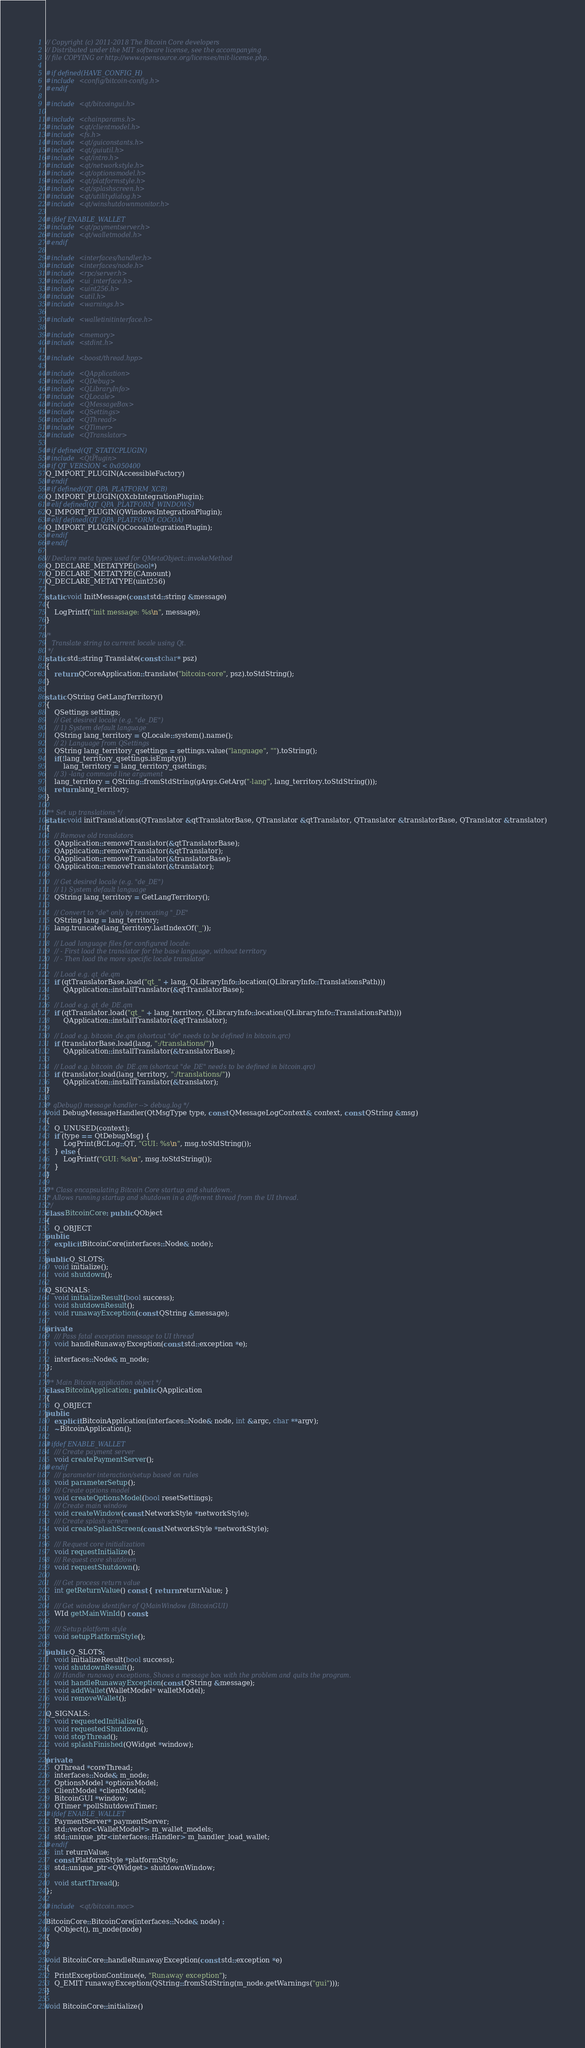Convert code to text. <code><loc_0><loc_0><loc_500><loc_500><_C++_>// Copyright (c) 2011-2018 The Bitcoin Core developers
// Distributed under the MIT software license, see the accompanying
// file COPYING or http://www.opensource.org/licenses/mit-license.php.

#if defined(HAVE_CONFIG_H)
#include <config/bitcoin-config.h>
#endif

#include <qt/bitcoingui.h>

#include <chainparams.h>
#include <qt/clientmodel.h>
#include <fs.h>
#include <qt/guiconstants.h>
#include <qt/guiutil.h>
#include <qt/intro.h>
#include <qt/networkstyle.h>
#include <qt/optionsmodel.h>
#include <qt/platformstyle.h>
#include <qt/splashscreen.h>
#include <qt/utilitydialog.h>
#include <qt/winshutdownmonitor.h>

#ifdef ENABLE_WALLET
#include <qt/paymentserver.h>
#include <qt/walletmodel.h>
#endif

#include <interfaces/handler.h>
#include <interfaces/node.h>
#include <rpc/server.h>
#include <ui_interface.h>
#include <uint256.h>
#include <util.h>
#include <warnings.h>

#include <walletinitinterface.h>

#include <memory>
#include <stdint.h>

#include <boost/thread.hpp>

#include <QApplication>
#include <QDebug>
#include <QLibraryInfo>
#include <QLocale>
#include <QMessageBox>
#include <QSettings>
#include <QThread>
#include <QTimer>
#include <QTranslator>

#if defined(QT_STATICPLUGIN)
#include <QtPlugin>
#if QT_VERSION < 0x050400
Q_IMPORT_PLUGIN(AccessibleFactory)
#endif
#if defined(QT_QPA_PLATFORM_XCB)
Q_IMPORT_PLUGIN(QXcbIntegrationPlugin);
#elif defined(QT_QPA_PLATFORM_WINDOWS)
Q_IMPORT_PLUGIN(QWindowsIntegrationPlugin);
#elif defined(QT_QPA_PLATFORM_COCOA)
Q_IMPORT_PLUGIN(QCocoaIntegrationPlugin);
#endif
#endif

// Declare meta types used for QMetaObject::invokeMethod
Q_DECLARE_METATYPE(bool*)
Q_DECLARE_METATYPE(CAmount)
Q_DECLARE_METATYPE(uint256)

static void InitMessage(const std::string &message)
{
    LogPrintf("init message: %s\n", message);
}

/*
   Translate string to current locale using Qt.
 */
static std::string Translate(const char* psz)
{
    return QCoreApplication::translate("bitcoin-core", psz).toStdString();
}

static QString GetLangTerritory()
{
    QSettings settings;
    // Get desired locale (e.g. "de_DE")
    // 1) System default language
    QString lang_territory = QLocale::system().name();
    // 2) Language from QSettings
    QString lang_territory_qsettings = settings.value("language", "").toString();
    if(!lang_territory_qsettings.isEmpty())
        lang_territory = lang_territory_qsettings;
    // 3) -lang command line argument
    lang_territory = QString::fromStdString(gArgs.GetArg("-lang", lang_territory.toStdString()));
    return lang_territory;
}

/** Set up translations */
static void initTranslations(QTranslator &qtTranslatorBase, QTranslator &qtTranslator, QTranslator &translatorBase, QTranslator &translator)
{
    // Remove old translators
    QApplication::removeTranslator(&qtTranslatorBase);
    QApplication::removeTranslator(&qtTranslator);
    QApplication::removeTranslator(&translatorBase);
    QApplication::removeTranslator(&translator);

    // Get desired locale (e.g. "de_DE")
    // 1) System default language
    QString lang_territory = GetLangTerritory();

    // Convert to "de" only by truncating "_DE"
    QString lang = lang_territory;
    lang.truncate(lang_territory.lastIndexOf('_'));

    // Load language files for configured locale:
    // - First load the translator for the base language, without territory
    // - Then load the more specific locale translator

    // Load e.g. qt_de.qm
    if (qtTranslatorBase.load("qt_" + lang, QLibraryInfo::location(QLibraryInfo::TranslationsPath)))
        QApplication::installTranslator(&qtTranslatorBase);

    // Load e.g. qt_de_DE.qm
    if (qtTranslator.load("qt_" + lang_territory, QLibraryInfo::location(QLibraryInfo::TranslationsPath)))
        QApplication::installTranslator(&qtTranslator);

    // Load e.g. bitcoin_de.qm (shortcut "de" needs to be defined in bitcoin.qrc)
    if (translatorBase.load(lang, ":/translations/"))
        QApplication::installTranslator(&translatorBase);

    // Load e.g. bitcoin_de_DE.qm (shortcut "de_DE" needs to be defined in bitcoin.qrc)
    if (translator.load(lang_territory, ":/translations/"))
        QApplication::installTranslator(&translator);
}

/* qDebug() message handler --> debug.log */
void DebugMessageHandler(QtMsgType type, const QMessageLogContext& context, const QString &msg)
{
    Q_UNUSED(context);
    if (type == QtDebugMsg) {
        LogPrint(BCLog::QT, "GUI: %s\n", msg.toStdString());
    } else {
        LogPrintf("GUI: %s\n", msg.toStdString());
    }
}

/** Class encapsulating Bitcoin Core startup and shutdown.
 * Allows running startup and shutdown in a different thread from the UI thread.
 */
class BitcoinCore: public QObject
{
    Q_OBJECT
public:
    explicit BitcoinCore(interfaces::Node& node);

public Q_SLOTS:
    void initialize();
    void shutdown();

Q_SIGNALS:
    void initializeResult(bool success);
    void shutdownResult();
    void runawayException(const QString &message);

private:
    /// Pass fatal exception message to UI thread
    void handleRunawayException(const std::exception *e);

    interfaces::Node& m_node;
};

/** Main Bitcoin application object */
class BitcoinApplication: public QApplication
{
    Q_OBJECT
public:
    explicit BitcoinApplication(interfaces::Node& node, int &argc, char **argv);
    ~BitcoinApplication();

#ifdef ENABLE_WALLET
    /// Create payment server
    void createPaymentServer();
#endif
    /// parameter interaction/setup based on rules
    void parameterSetup();
    /// Create options model
    void createOptionsModel(bool resetSettings);
    /// Create main window
    void createWindow(const NetworkStyle *networkStyle);
    /// Create splash screen
    void createSplashScreen(const NetworkStyle *networkStyle);

    /// Request core initialization
    void requestInitialize();
    /// Request core shutdown
    void requestShutdown();

    /// Get process return value
    int getReturnValue() const { return returnValue; }

    /// Get window identifier of QMainWindow (BitcoinGUI)
    WId getMainWinId() const;

    /// Setup platform style
    void setupPlatformStyle();

public Q_SLOTS:
    void initializeResult(bool success);
    void shutdownResult();
    /// Handle runaway exceptions. Shows a message box with the problem and quits the program.
    void handleRunawayException(const QString &message);
    void addWallet(WalletModel* walletModel);
    void removeWallet();

Q_SIGNALS:
    void requestedInitialize();
    void requestedShutdown();
    void stopThread();
    void splashFinished(QWidget *window);

private:
    QThread *coreThread;
    interfaces::Node& m_node;
    OptionsModel *optionsModel;
    ClientModel *clientModel;
    BitcoinGUI *window;
    QTimer *pollShutdownTimer;
#ifdef ENABLE_WALLET
    PaymentServer* paymentServer;
    std::vector<WalletModel*> m_wallet_models;
    std::unique_ptr<interfaces::Handler> m_handler_load_wallet;
#endif
    int returnValue;
    const PlatformStyle *platformStyle;
    std::unique_ptr<QWidget> shutdownWindow;

    void startThread();
};

#include <qt/bitcoin.moc>

BitcoinCore::BitcoinCore(interfaces::Node& node) :
    QObject(), m_node(node)
{
}

void BitcoinCore::handleRunawayException(const std::exception *e)
{
    PrintExceptionContinue(e, "Runaway exception");
    Q_EMIT runawayException(QString::fromStdString(m_node.getWarnings("gui")));
}

void BitcoinCore::initialize()</code> 